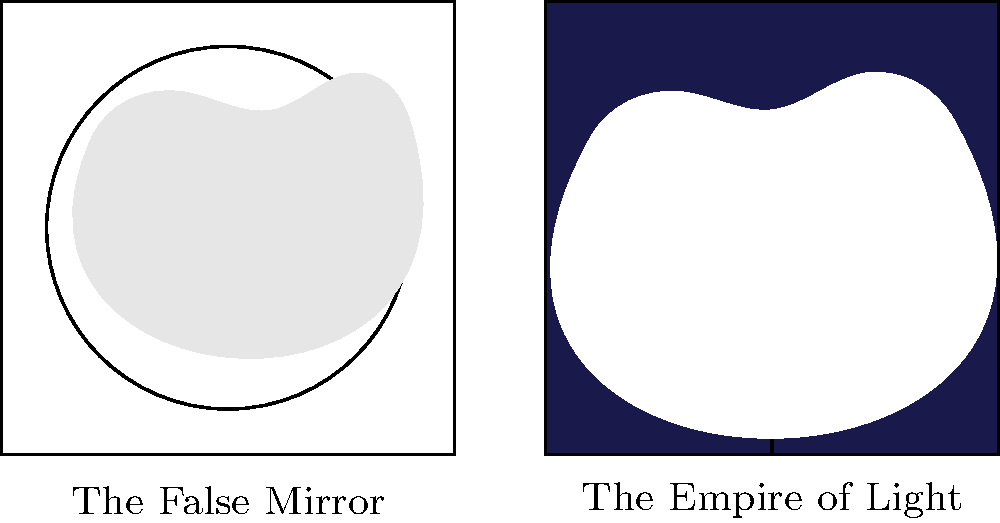Compare Magritte's use of clouds in "The False Mirror" and "The Empire of Light." How does the context and color of the clouds differ between these two paintings, and what effect does this create? 1. "The False Mirror" (1928):
   - Clouds are depicted within an eye.
   - They are painted in light gray, contrasting with the blue iris.
   - The clouds appear surreal and dreamlike in this context.
   - They suggest the eye is reflecting the sky, blurring reality and imagination.

2. "The Empire of Light" (1953-54):
   - Clouds are shown in a night sky scene.
   - They are painted white, contrasting sharply with the dark sky.
   - The clouds appear more naturalistic but create a paradox.
   - They suggest daylight in a nighttime scene, challenging our perception of time.

3. Comparison:
   - In "The False Mirror," clouds are used to create a surreal, internal landscape.
   - In "The Empire of Light," clouds are used to create a paradoxical external landscape.
   - Both uses of clouds challenge reality and perception, but in different ways.
   - The color contrast is more pronounced in "The Empire of Light."

4. Effect:
   - Both paintings use clouds to create a sense of disorientation and wonder.
   - They challenge the viewer's expectations and understanding of reality.
   - The clouds serve as a key element in Magritte's exploration of the relationship between visible things and their representation.
Answer: Surreal internal landscape vs. paradoxical external landscape; both challenge reality through contrasting contexts and colors. 